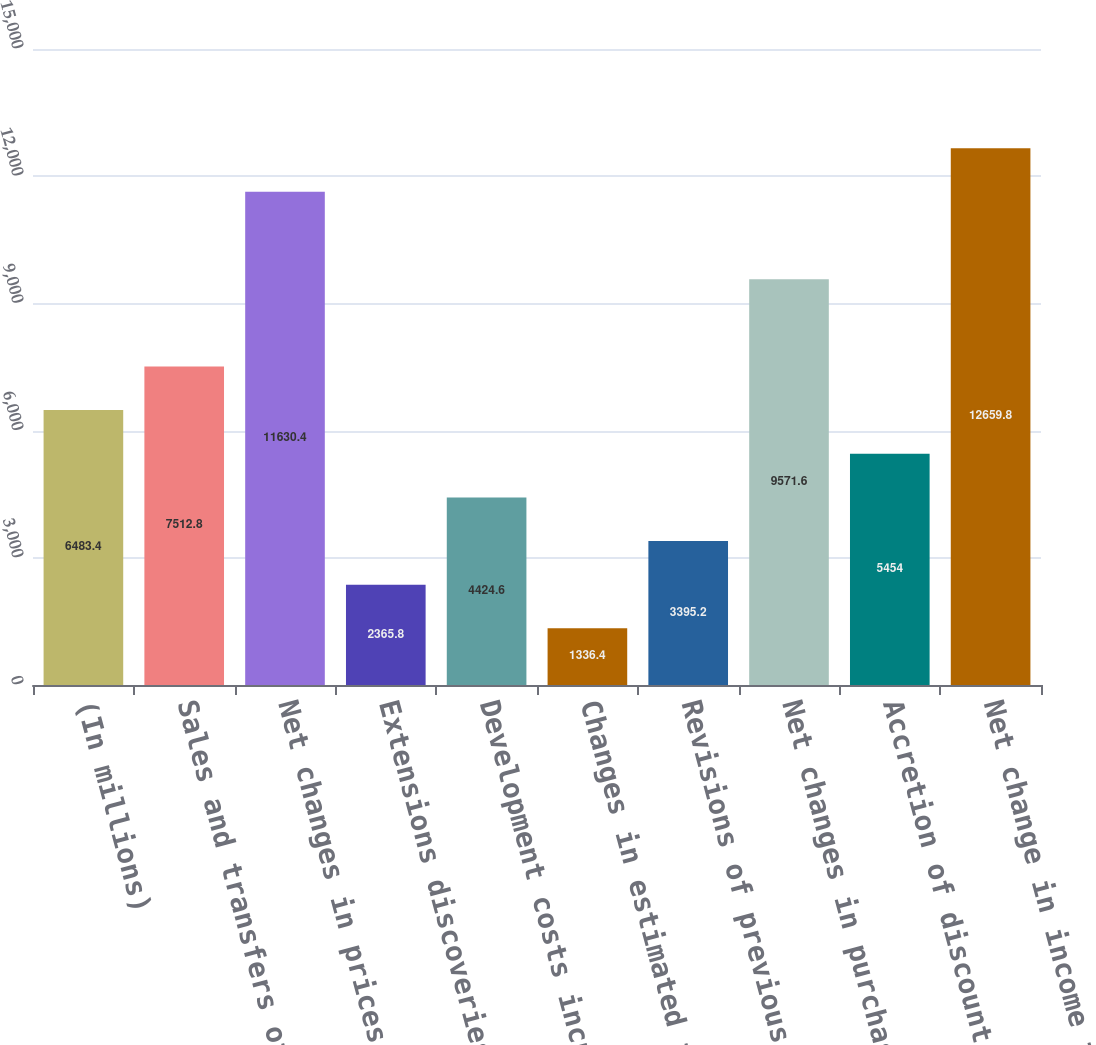Convert chart. <chart><loc_0><loc_0><loc_500><loc_500><bar_chart><fcel>(In millions)<fcel>Sales and transfers of oil and<fcel>Net changes in prices and<fcel>Extensions discoveries and<fcel>Development costs incurred<fcel>Changes in estimated future<fcel>Revisions of previous quantity<fcel>Net changes in purchases and<fcel>Accretion of discount<fcel>Net change in income taxes<nl><fcel>6483.4<fcel>7512.8<fcel>11630.4<fcel>2365.8<fcel>4424.6<fcel>1336.4<fcel>3395.2<fcel>9571.6<fcel>5454<fcel>12659.8<nl></chart> 